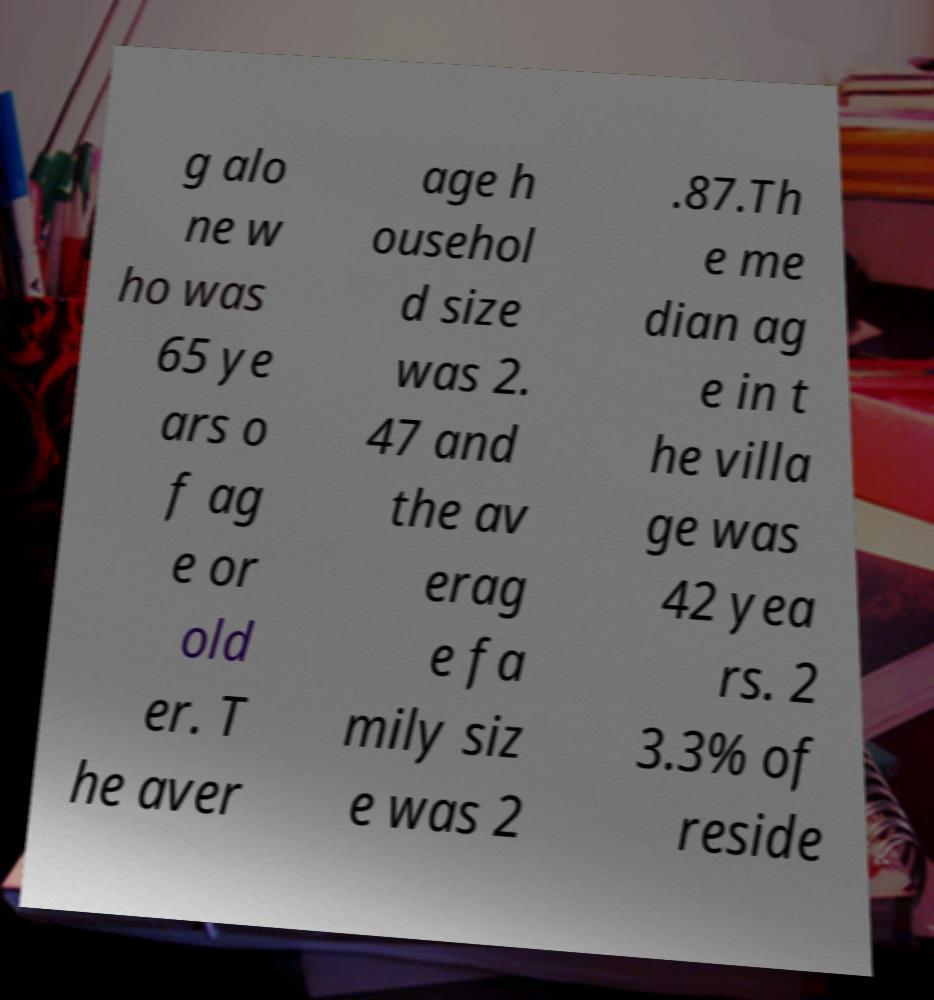What messages or text are displayed in this image? I need them in a readable, typed format. g alo ne w ho was 65 ye ars o f ag e or old er. T he aver age h ousehol d size was 2. 47 and the av erag e fa mily siz e was 2 .87.Th e me dian ag e in t he villa ge was 42 yea rs. 2 3.3% of reside 